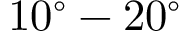<formula> <loc_0><loc_0><loc_500><loc_500>1 0 ^ { \circ } - 2 0 ^ { \circ }</formula> 